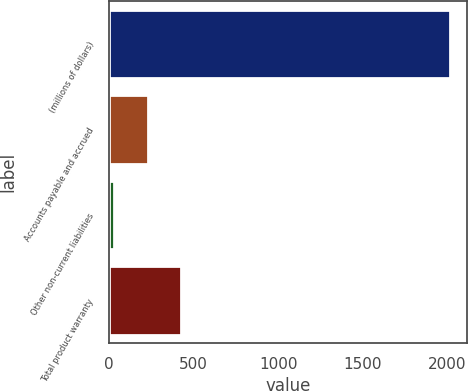Convert chart. <chart><loc_0><loc_0><loc_500><loc_500><bar_chart><fcel>(millions of dollars)<fcel>Accounts payable and accrued<fcel>Other non-current liabilities<fcel>Total product warranty<nl><fcel>2016<fcel>229.86<fcel>31.4<fcel>428.32<nl></chart> 